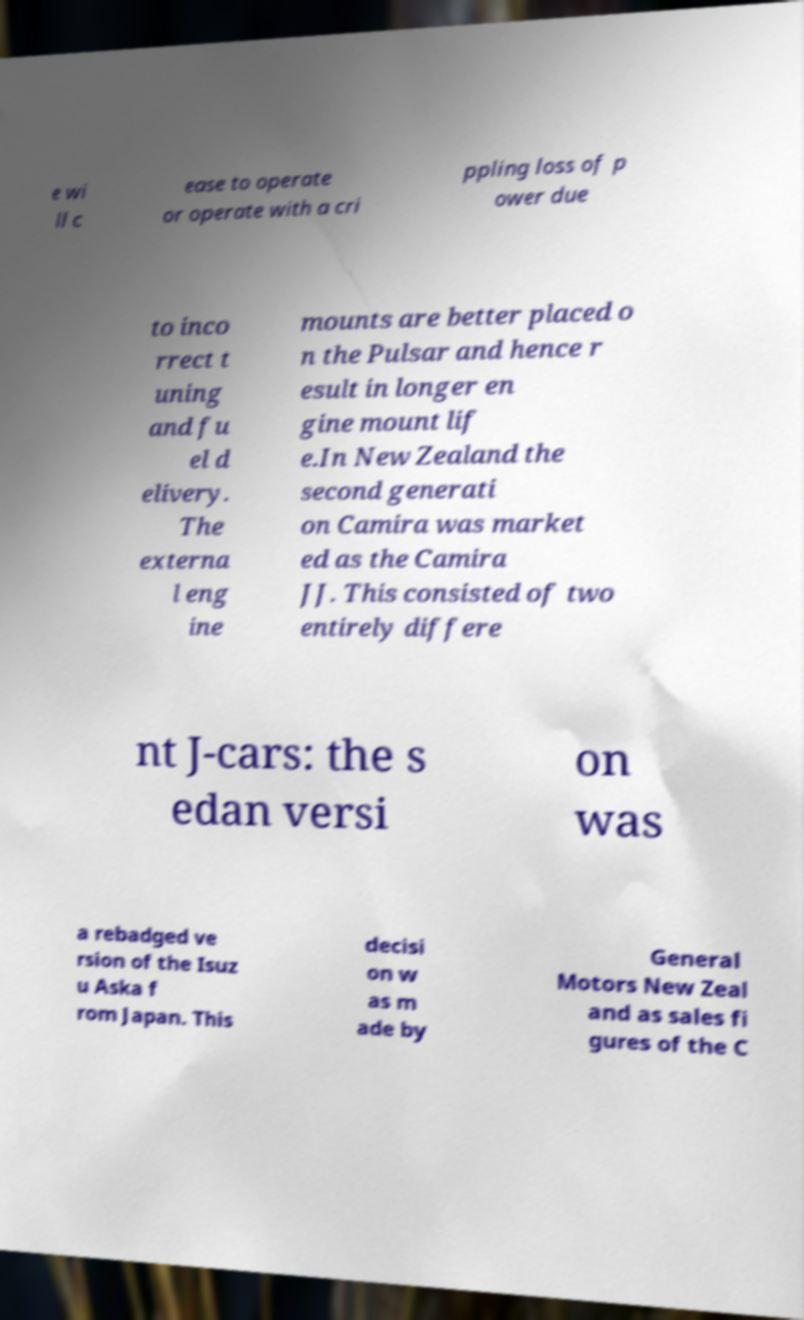Could you extract and type out the text from this image? e wi ll c ease to operate or operate with a cri ppling loss of p ower due to inco rrect t uning and fu el d elivery. The externa l eng ine mounts are better placed o n the Pulsar and hence r esult in longer en gine mount lif e.In New Zealand the second generati on Camira was market ed as the Camira JJ. This consisted of two entirely differe nt J-cars: the s edan versi on was a rebadged ve rsion of the Isuz u Aska f rom Japan. This decisi on w as m ade by General Motors New Zeal and as sales fi gures of the C 